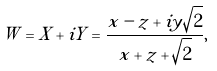<formula> <loc_0><loc_0><loc_500><loc_500>W = X + i Y = \frac { x - z + i y \sqrt { 2 } } { x + z + \sqrt { 2 } } ,</formula> 